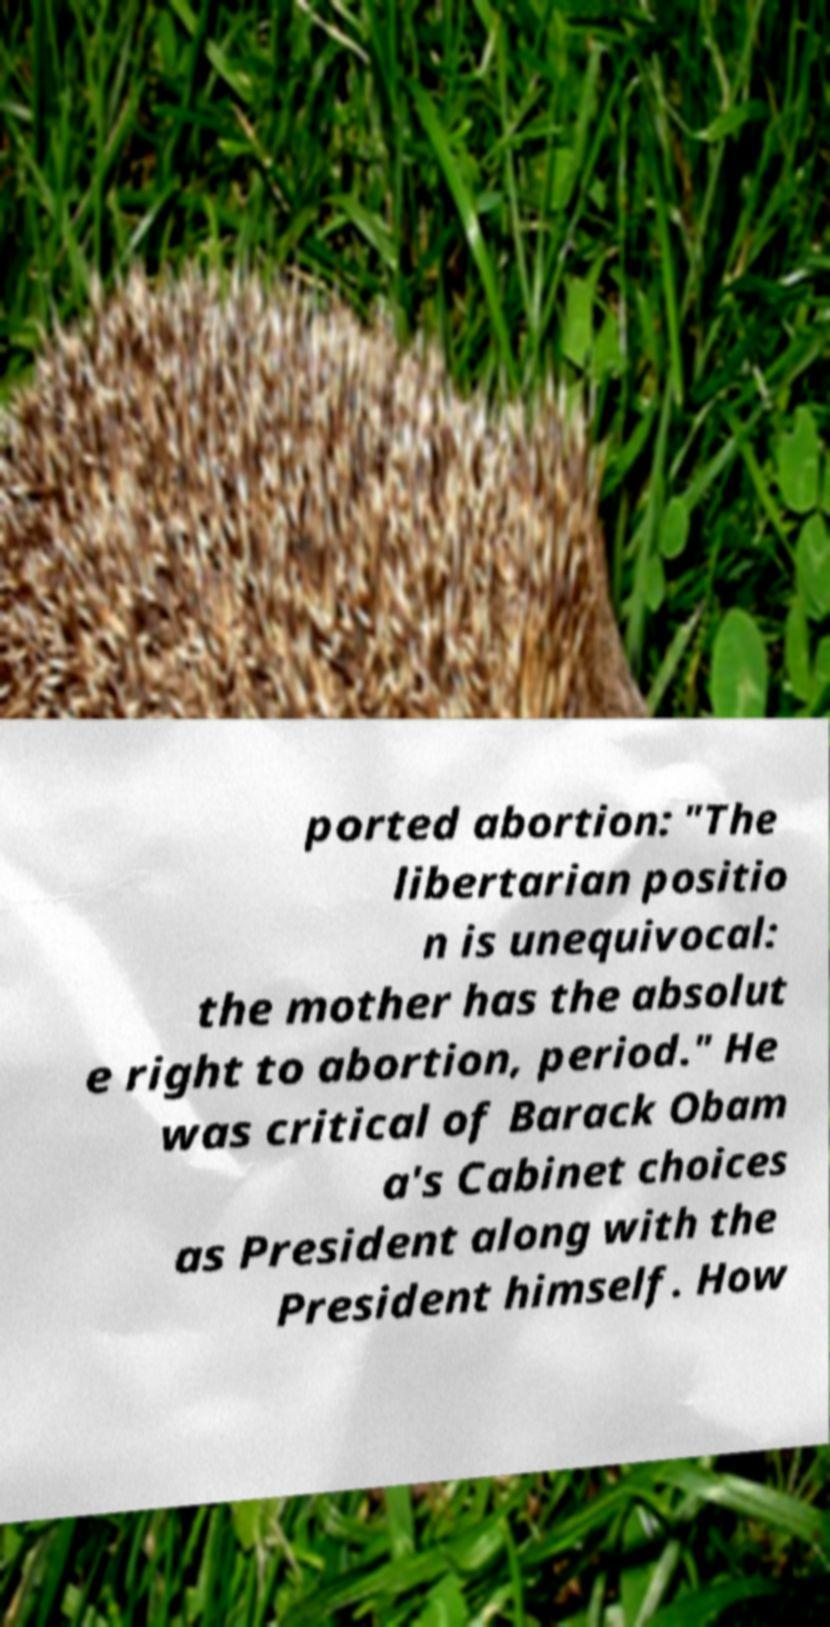Could you extract and type out the text from this image? ported abortion: "The libertarian positio n is unequivocal: the mother has the absolut e right to abortion, period." He was critical of Barack Obam a's Cabinet choices as President along with the President himself. How 